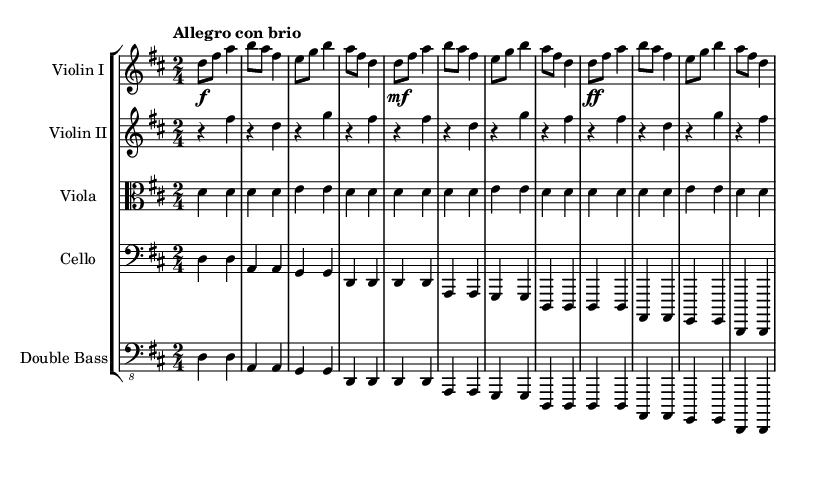What is the key signature of this music? The key signature is determined by the number of sharps or flats shown at the beginning of the music staff. In this case, there are two sharps indicated, which corresponds to D major.
Answer: D major What is the time signature of this music? The time signature is represented by the numbers placed after the clef sign. Here, it shows a "2/4," meaning there are 2 beats per measure and a quarter note receives one beat.
Answer: 2/4 What is the tempo marking for this piece? The tempo marking is indicated near the beginning of the score, reading "Allegro con brio." This indicates a fast tempo, full of vigor.
Answer: Allegro con brio How many measures are there in the violin I part? To find the number of measures, we can count each set of notation separated by vertical bars on the staff. There are 12 measures in the violin I part.
Answer: 12 What is the dynamic marking at the beginning of the violin I part? The dynamic marking is indicated by the symbol "f," which represents "forte," meaning to play loud. This marking is located at the start of the first measure.
Answer: forte Which instruments are included in this score? The score lists the instruments at the start of each staff. They include Violin I, Violin II, Viola, Cello, and Double Bass. Each instrument has its individual notation.
Answer: Violin I, Violin II, Viola, Cello, Double Bass What is the lowest note in the cello part? The lowest note can be identified by examining the bass clef notation, which shows the notes being played. The lowest note in this part is a D.
Answer: D 